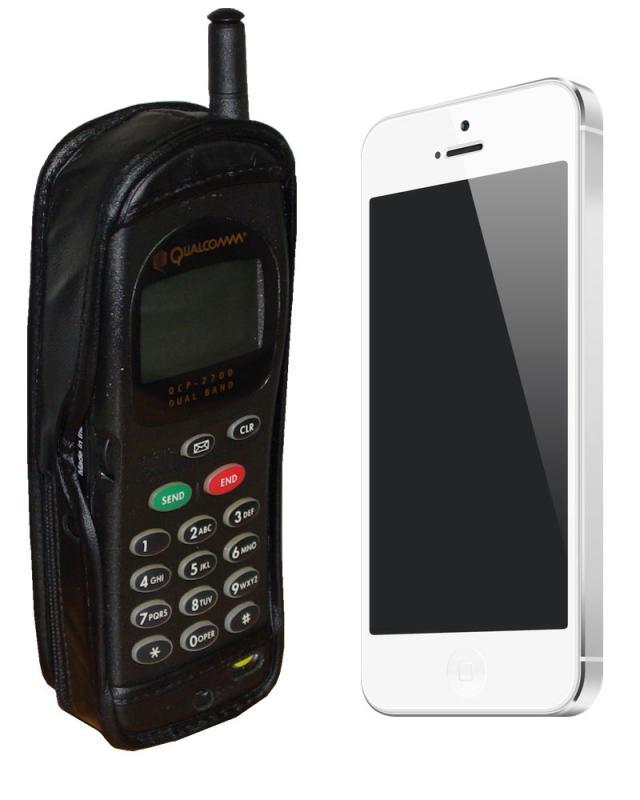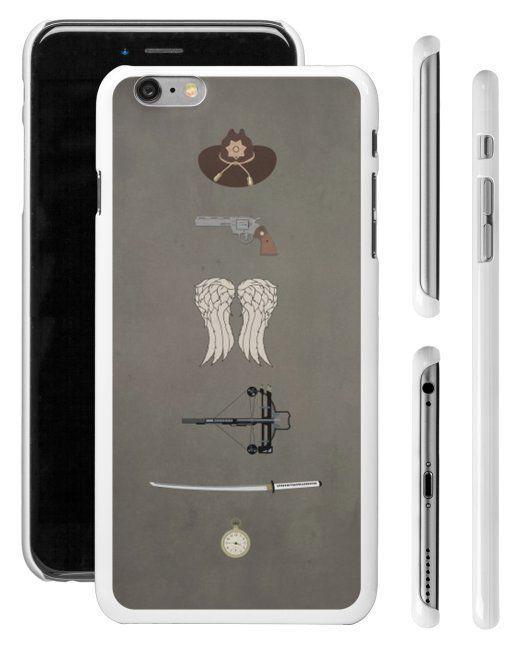The first image is the image on the left, the second image is the image on the right. Assess this claim about the two images: "At least one image includes a side-view of a phone to the right of two head-on displayed devices.". Correct or not? Answer yes or no. Yes. The first image is the image on the left, the second image is the image on the right. Examine the images to the left and right. Is the description "There is a side profile of at least one phone." accurate? Answer yes or no. Yes. 